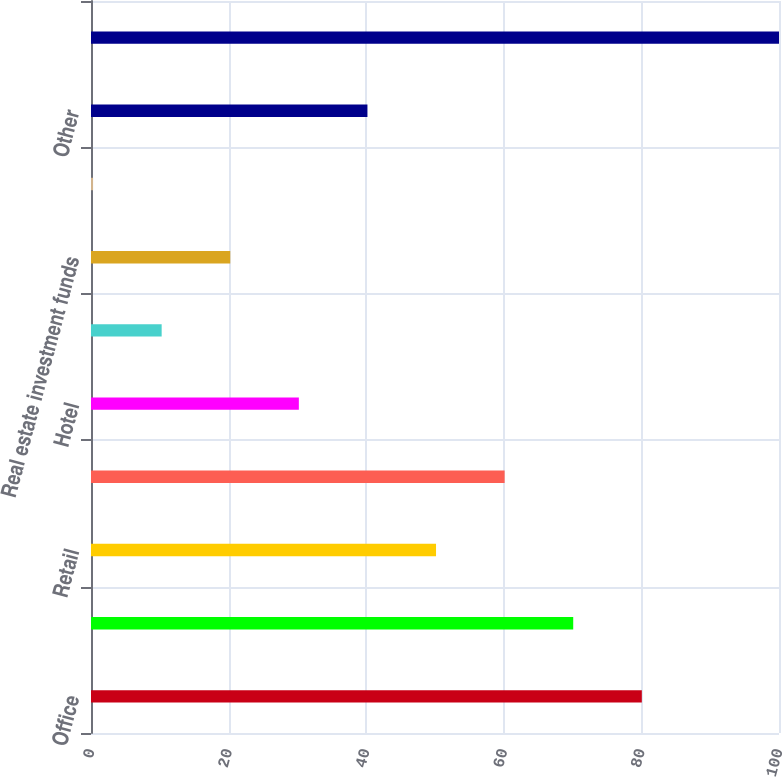Convert chart. <chart><loc_0><loc_0><loc_500><loc_500><bar_chart><fcel>Office<fcel>Apartment<fcel>Retail<fcel>Industrial<fcel>Hotel<fcel>Land<fcel>Real estate investment funds<fcel>Agriculture<fcel>Other<fcel>Total real estate and real<nl><fcel>80.06<fcel>70.09<fcel>50.15<fcel>60.12<fcel>30.21<fcel>10.27<fcel>20.24<fcel>0.3<fcel>40.18<fcel>100<nl></chart> 